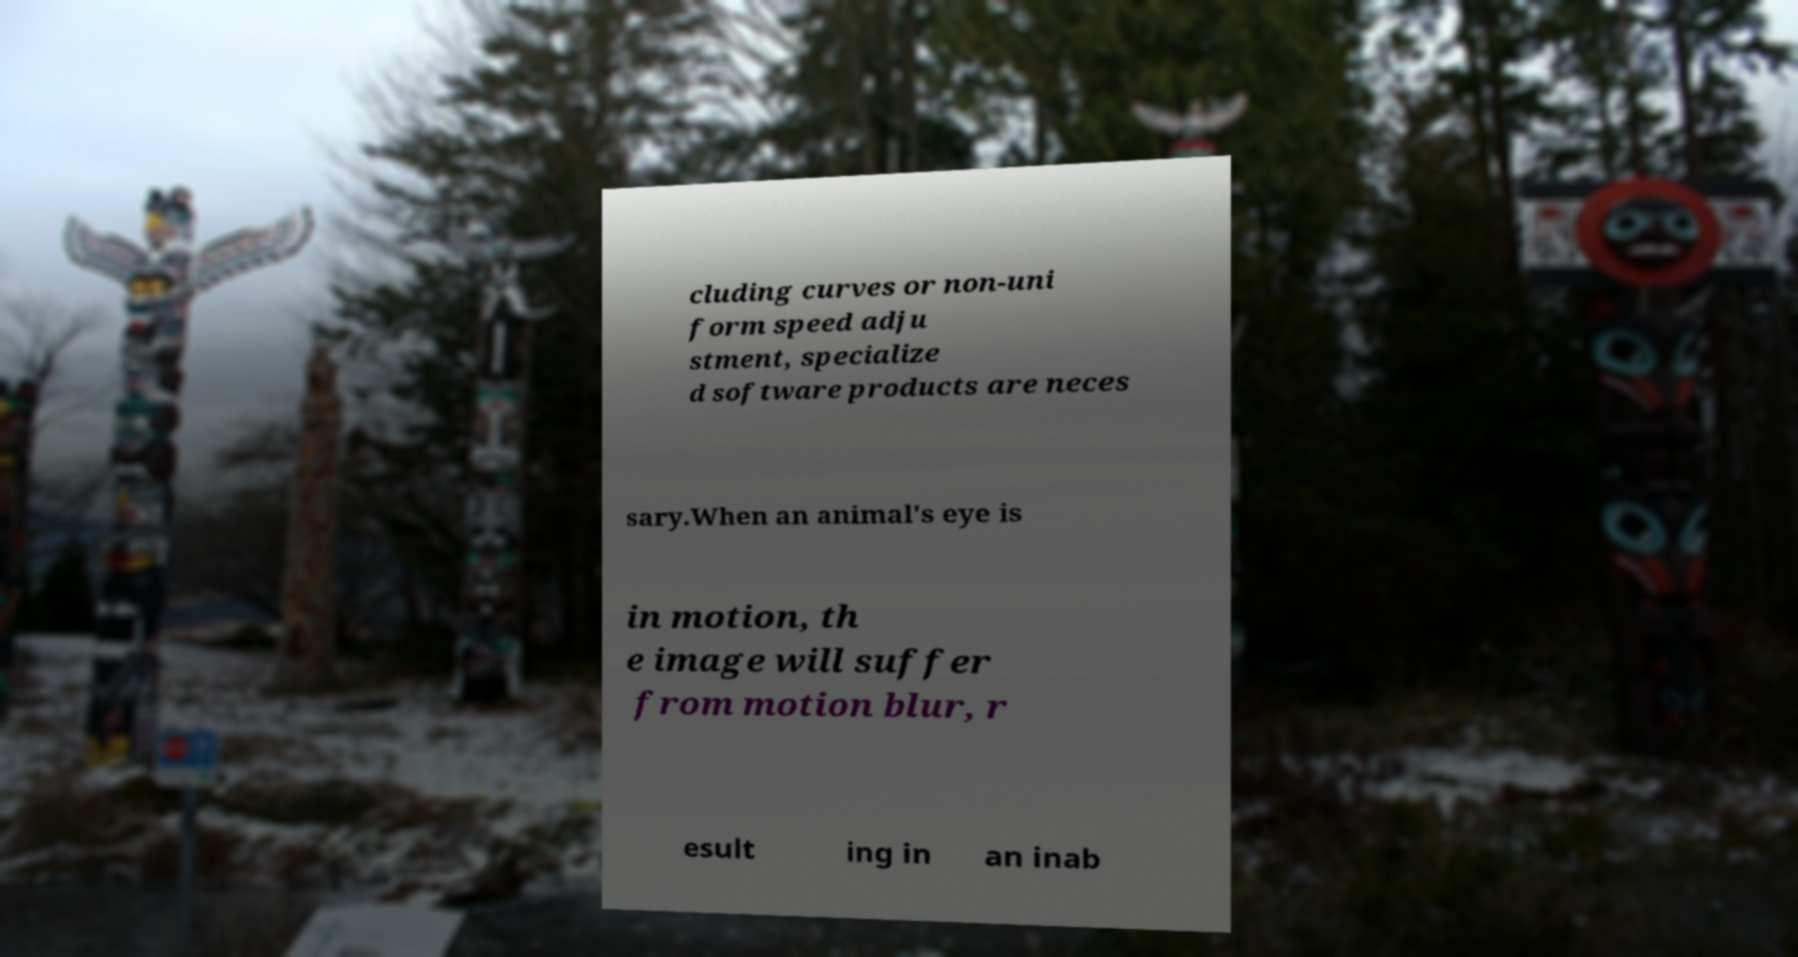Could you extract and type out the text from this image? cluding curves or non-uni form speed adju stment, specialize d software products are neces sary.When an animal's eye is in motion, th e image will suffer from motion blur, r esult ing in an inab 